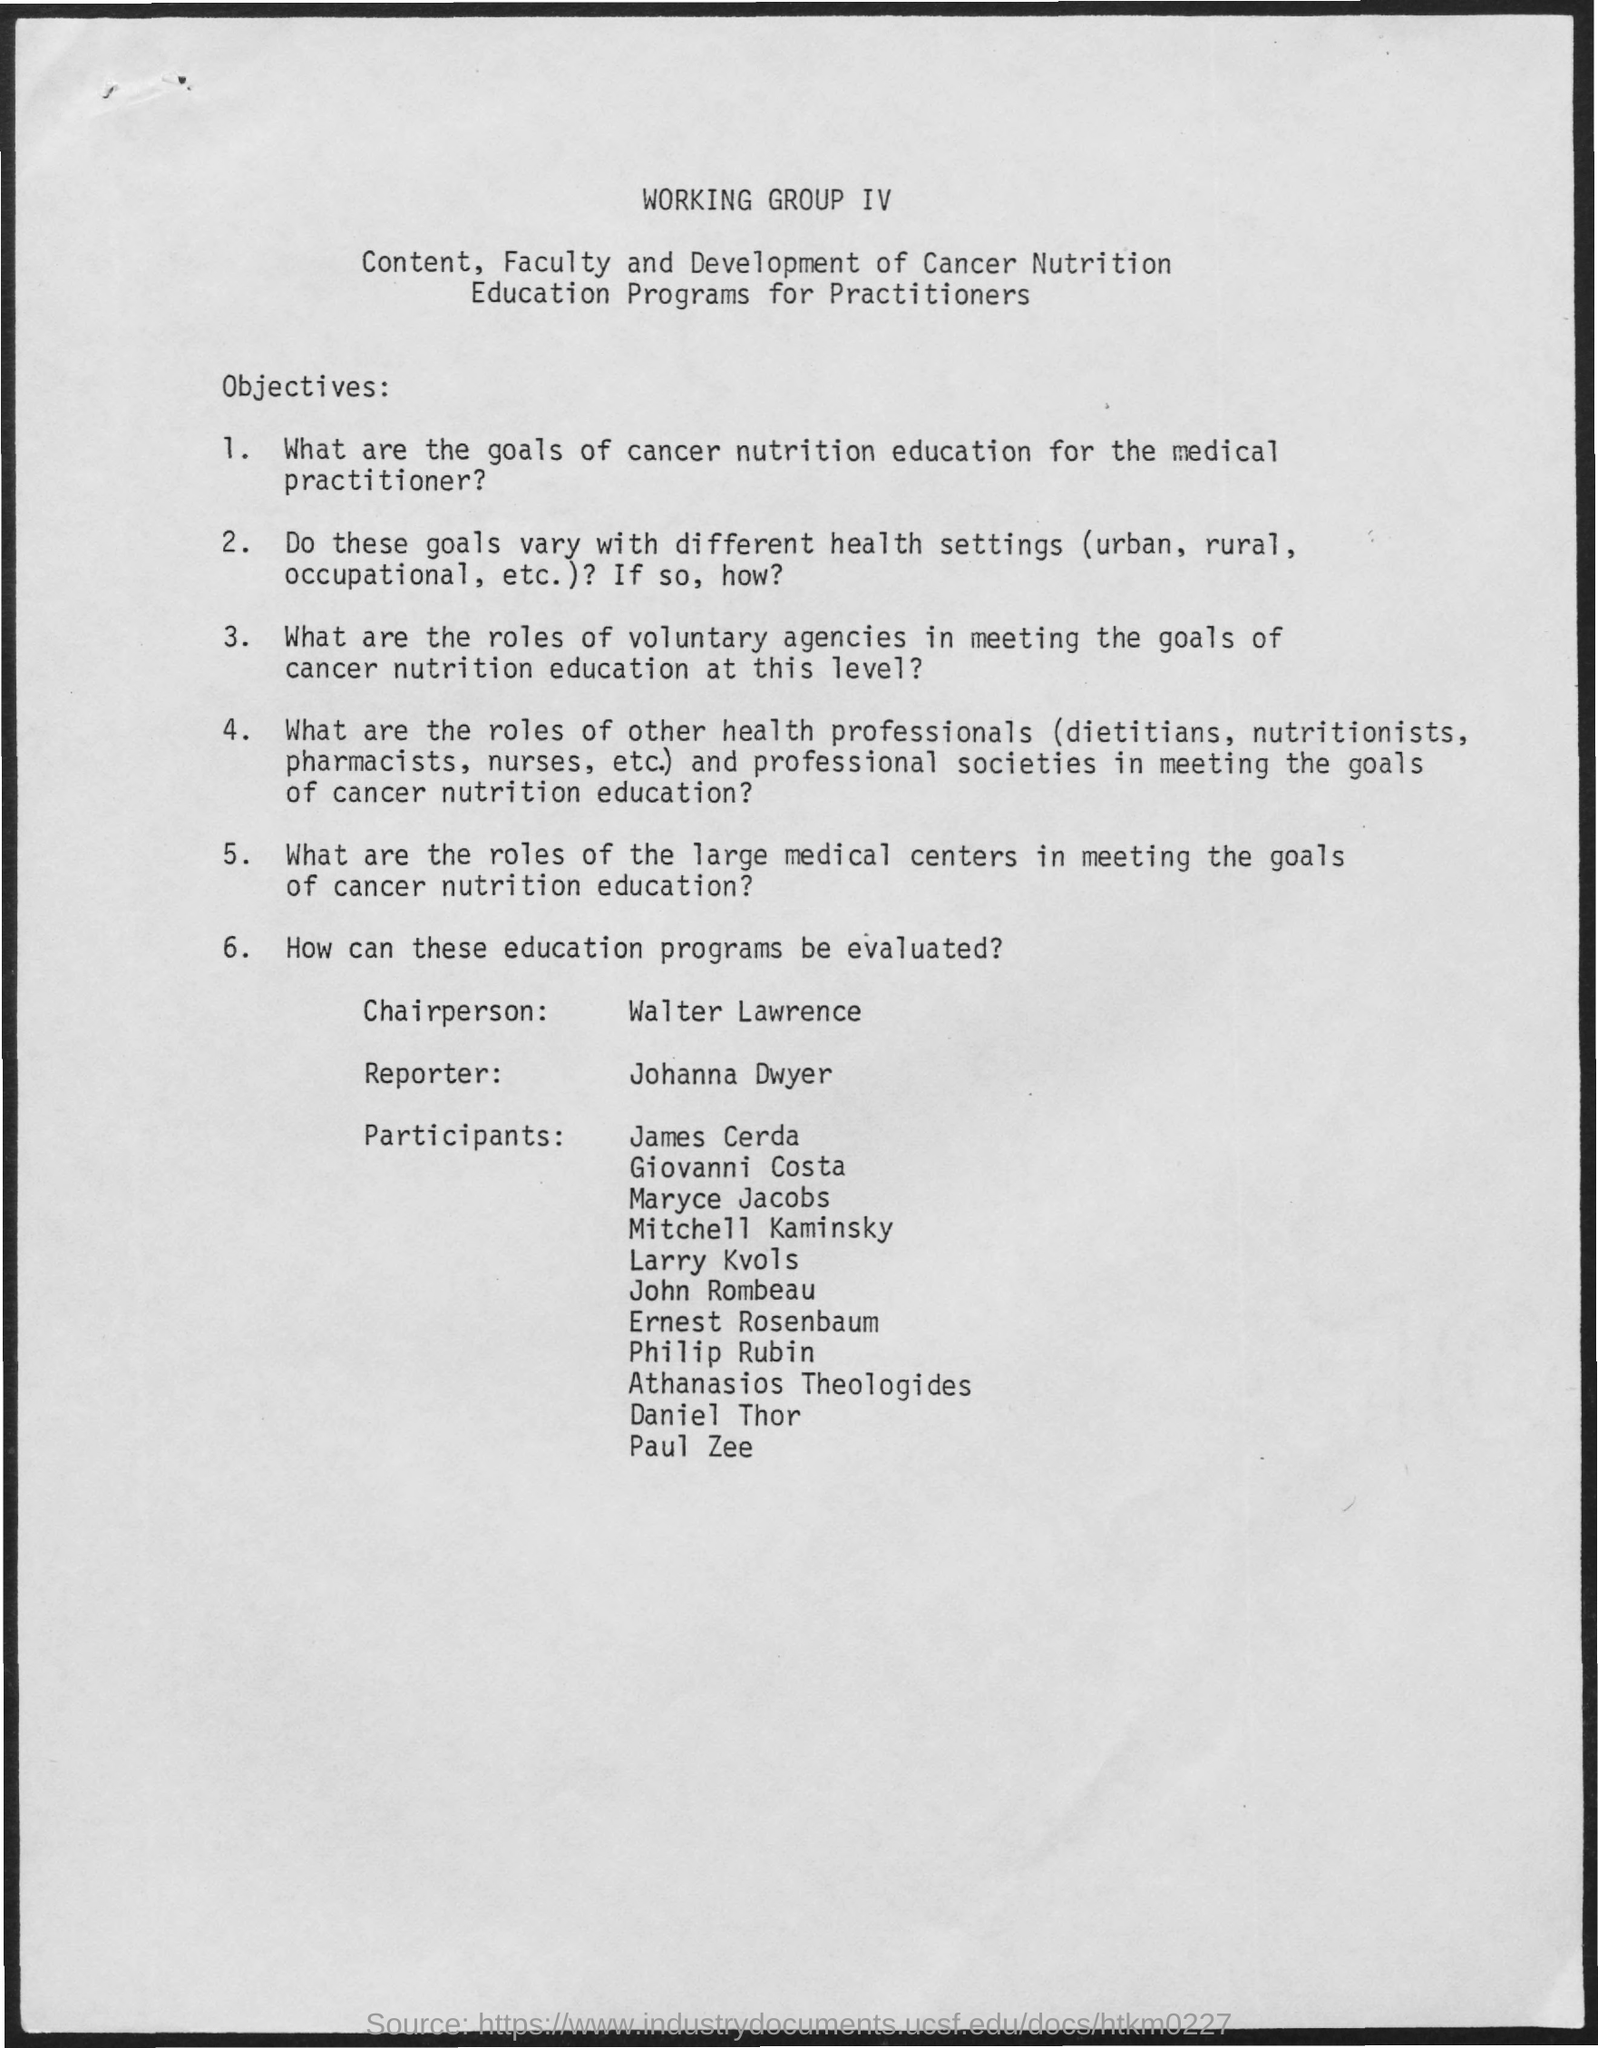Could you provide more information about the type of participants involved in this group and their potential roles? The participants listed in the document appear to come from diverse professional backgrounds, which likely include physicians, dietitians, nutrition experts, and possibly researchers. Their roles could involve sharing expertise to collaboratively define standards and strategies for teaching nutrition concepts to medical professionals, specifically targeted towards improving patient care for those with cancer. 